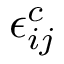Convert formula to latex. <formula><loc_0><loc_0><loc_500><loc_500>\epsilon _ { i j } ^ { c }</formula> 